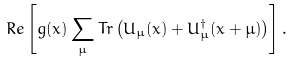<formula> <loc_0><loc_0><loc_500><loc_500>R e \left [ g ( x ) \sum _ { \mu } T r \left ( U _ { \mu } ( x ) + U ^ { \dagger } _ { \mu } ( x + \mu ) \right ) \right ] .</formula> 